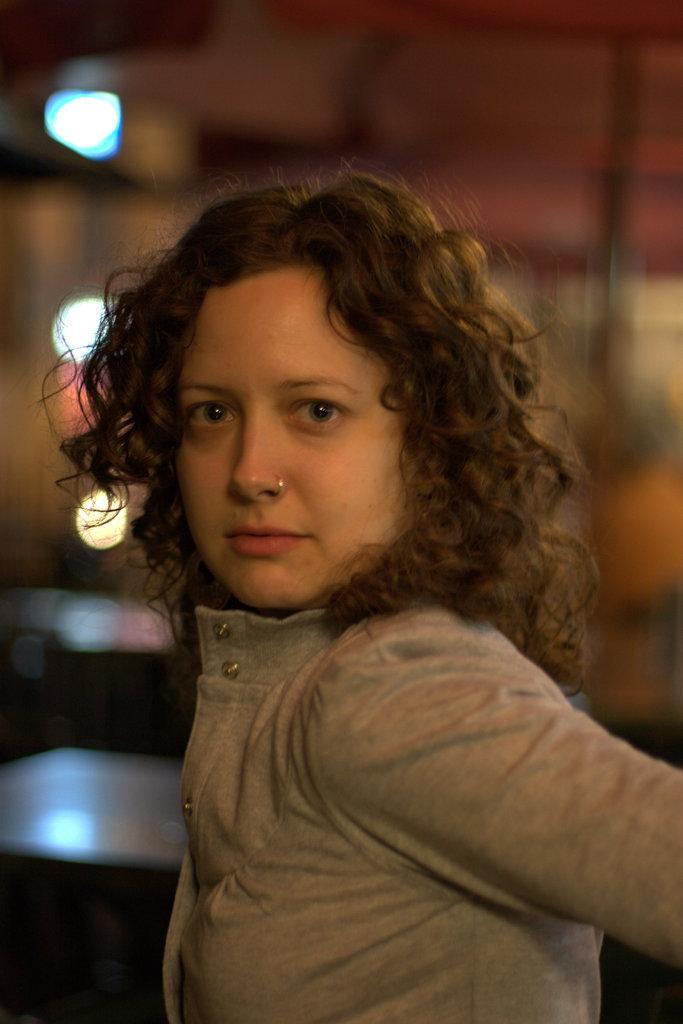Could you give a brief overview of what you see in this image? This is a zoomed in picture. In the foreground there is a woman. The background of the image is blurry and we can see the lights and some other objects in the background. 